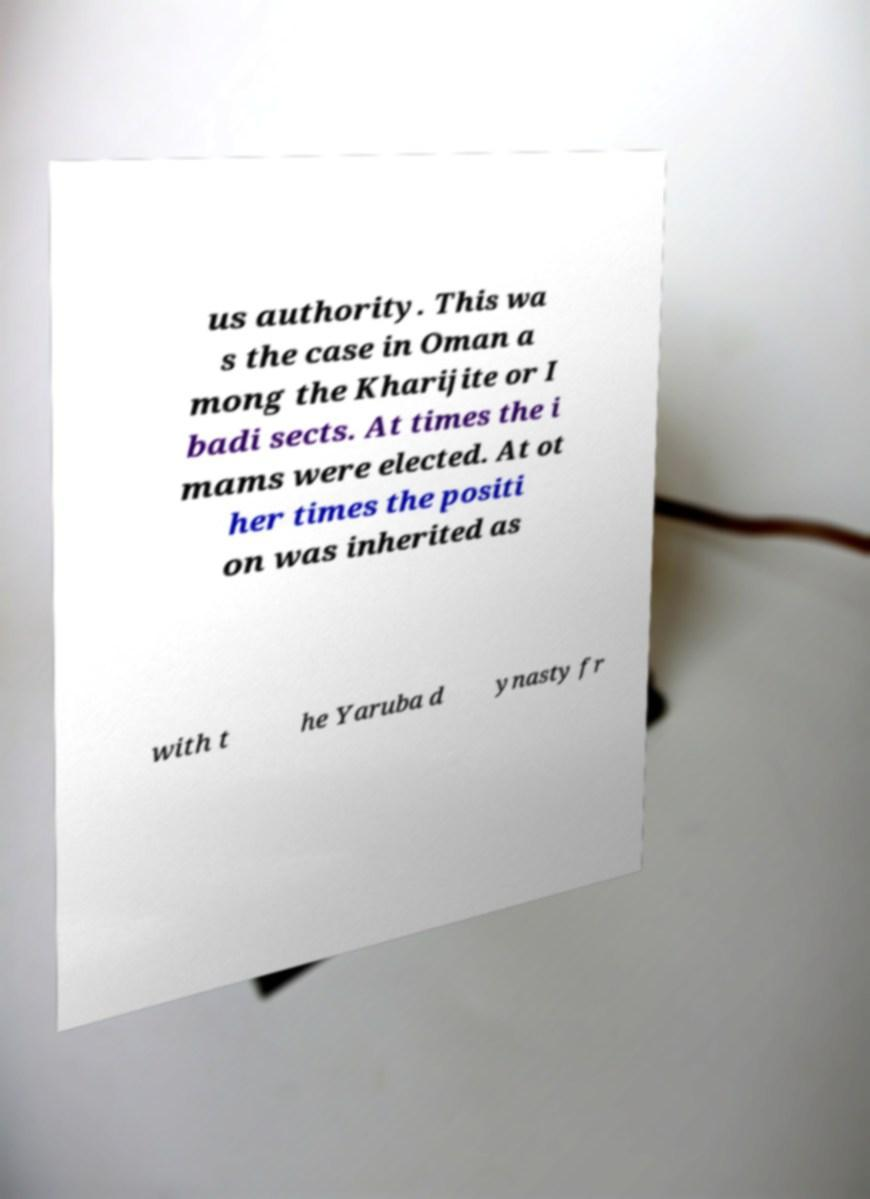I need the written content from this picture converted into text. Can you do that? us authority. This wa s the case in Oman a mong the Kharijite or I badi sects. At times the i mams were elected. At ot her times the positi on was inherited as with t he Yaruba d ynasty fr 